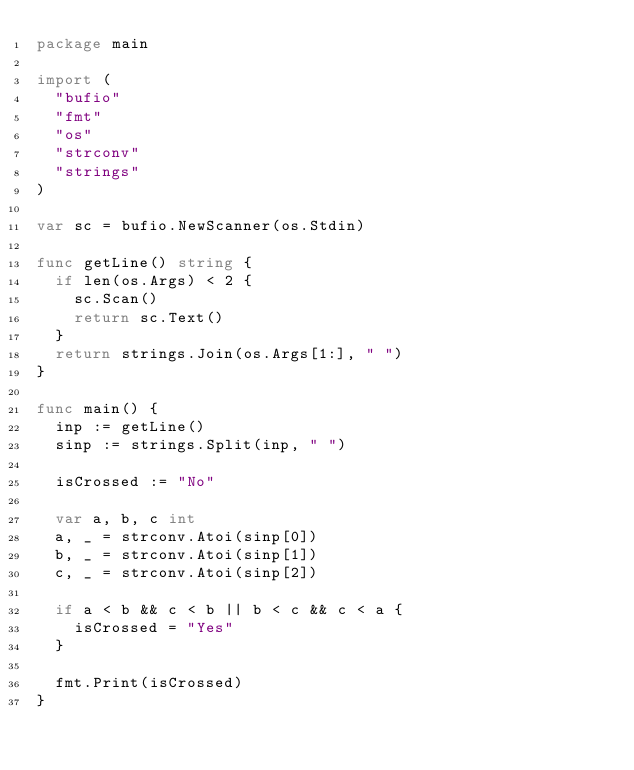<code> <loc_0><loc_0><loc_500><loc_500><_Go_>package main

import (
	"bufio"
	"fmt"
	"os"
	"strconv"
	"strings"
)

var sc = bufio.NewScanner(os.Stdin)

func getLine() string {
	if len(os.Args) < 2 {
		sc.Scan()
		return sc.Text()
	}
	return strings.Join(os.Args[1:], " ")
}

func main() {
	inp := getLine()
	sinp := strings.Split(inp, " ")

	isCrossed := "No"

	var a, b, c int
	a, _ = strconv.Atoi(sinp[0])
	b, _ = strconv.Atoi(sinp[1])
	c, _ = strconv.Atoi(sinp[2])

	if a < b && c < b || b < c && c < a {
		isCrossed = "Yes"
	}

	fmt.Print(isCrossed)
}
</code> 